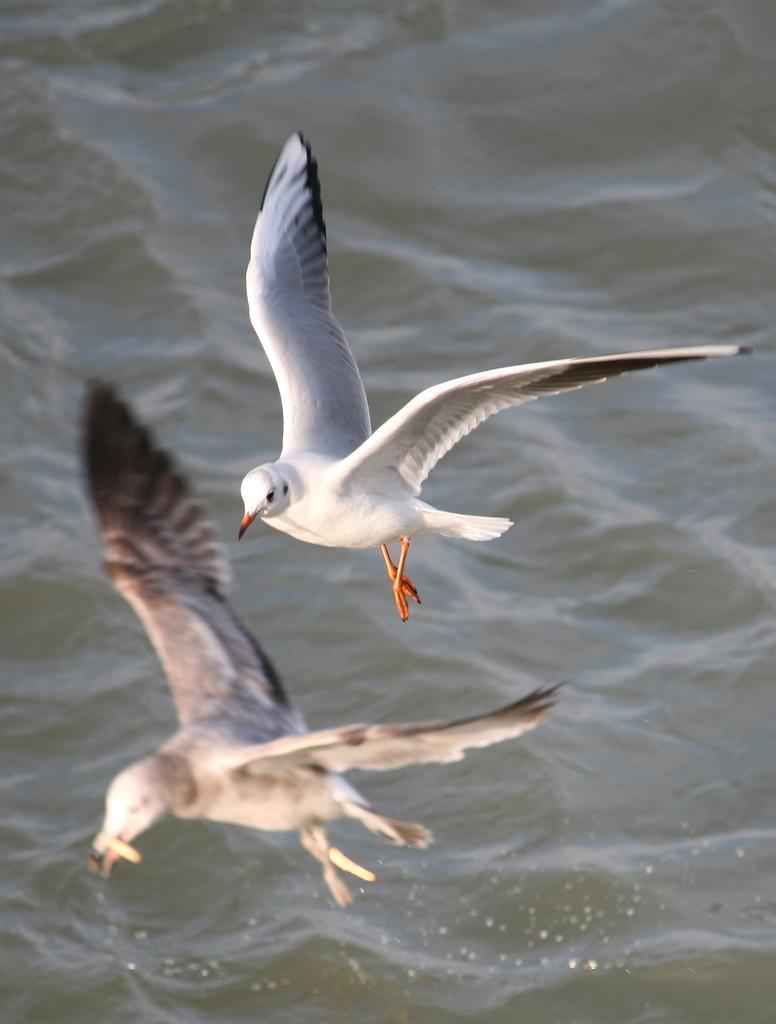Describe this image in one or two sentences. In this picture we can see couple of birds in the air, and also we can see water. 